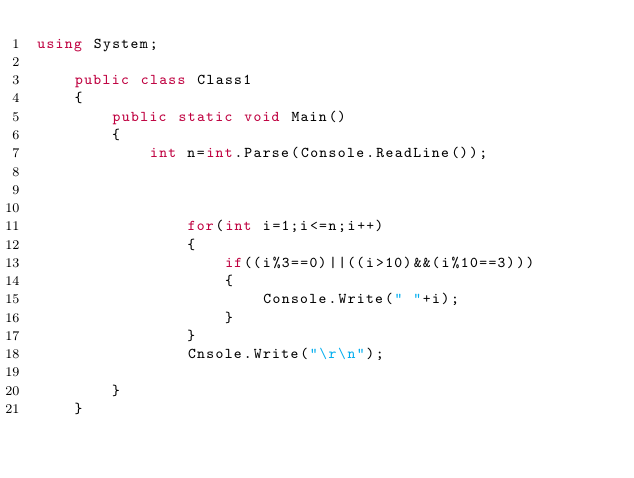Convert code to text. <code><loc_0><loc_0><loc_500><loc_500><_C#_>using System;

	public class Class1
	{
		public static void Main()
		{  
			int n=int.Parse(Console.ReadLine());
				
				
				
				for(int i=1;i<=n;i++)
				{
					if((i%3==0)||((i>10)&&(i%10==3)))
					{
						Console.Write(" "+i);
					}
				}
				Cnsole.Write("\r\n");
				
		}
	}
			    </code> 